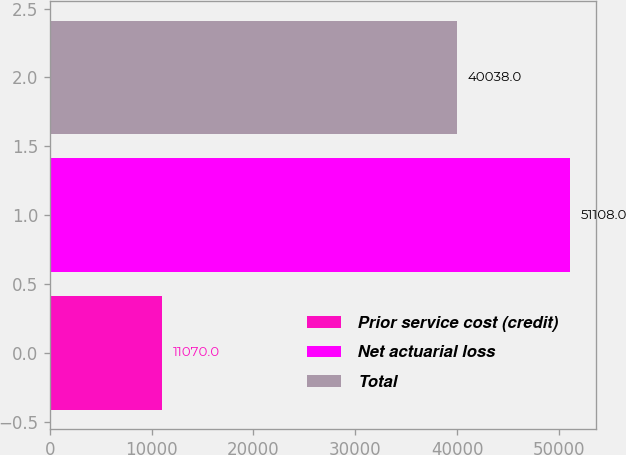Convert chart. <chart><loc_0><loc_0><loc_500><loc_500><bar_chart><fcel>Prior service cost (credit)<fcel>Net actuarial loss<fcel>Total<nl><fcel>11070<fcel>51108<fcel>40038<nl></chart> 